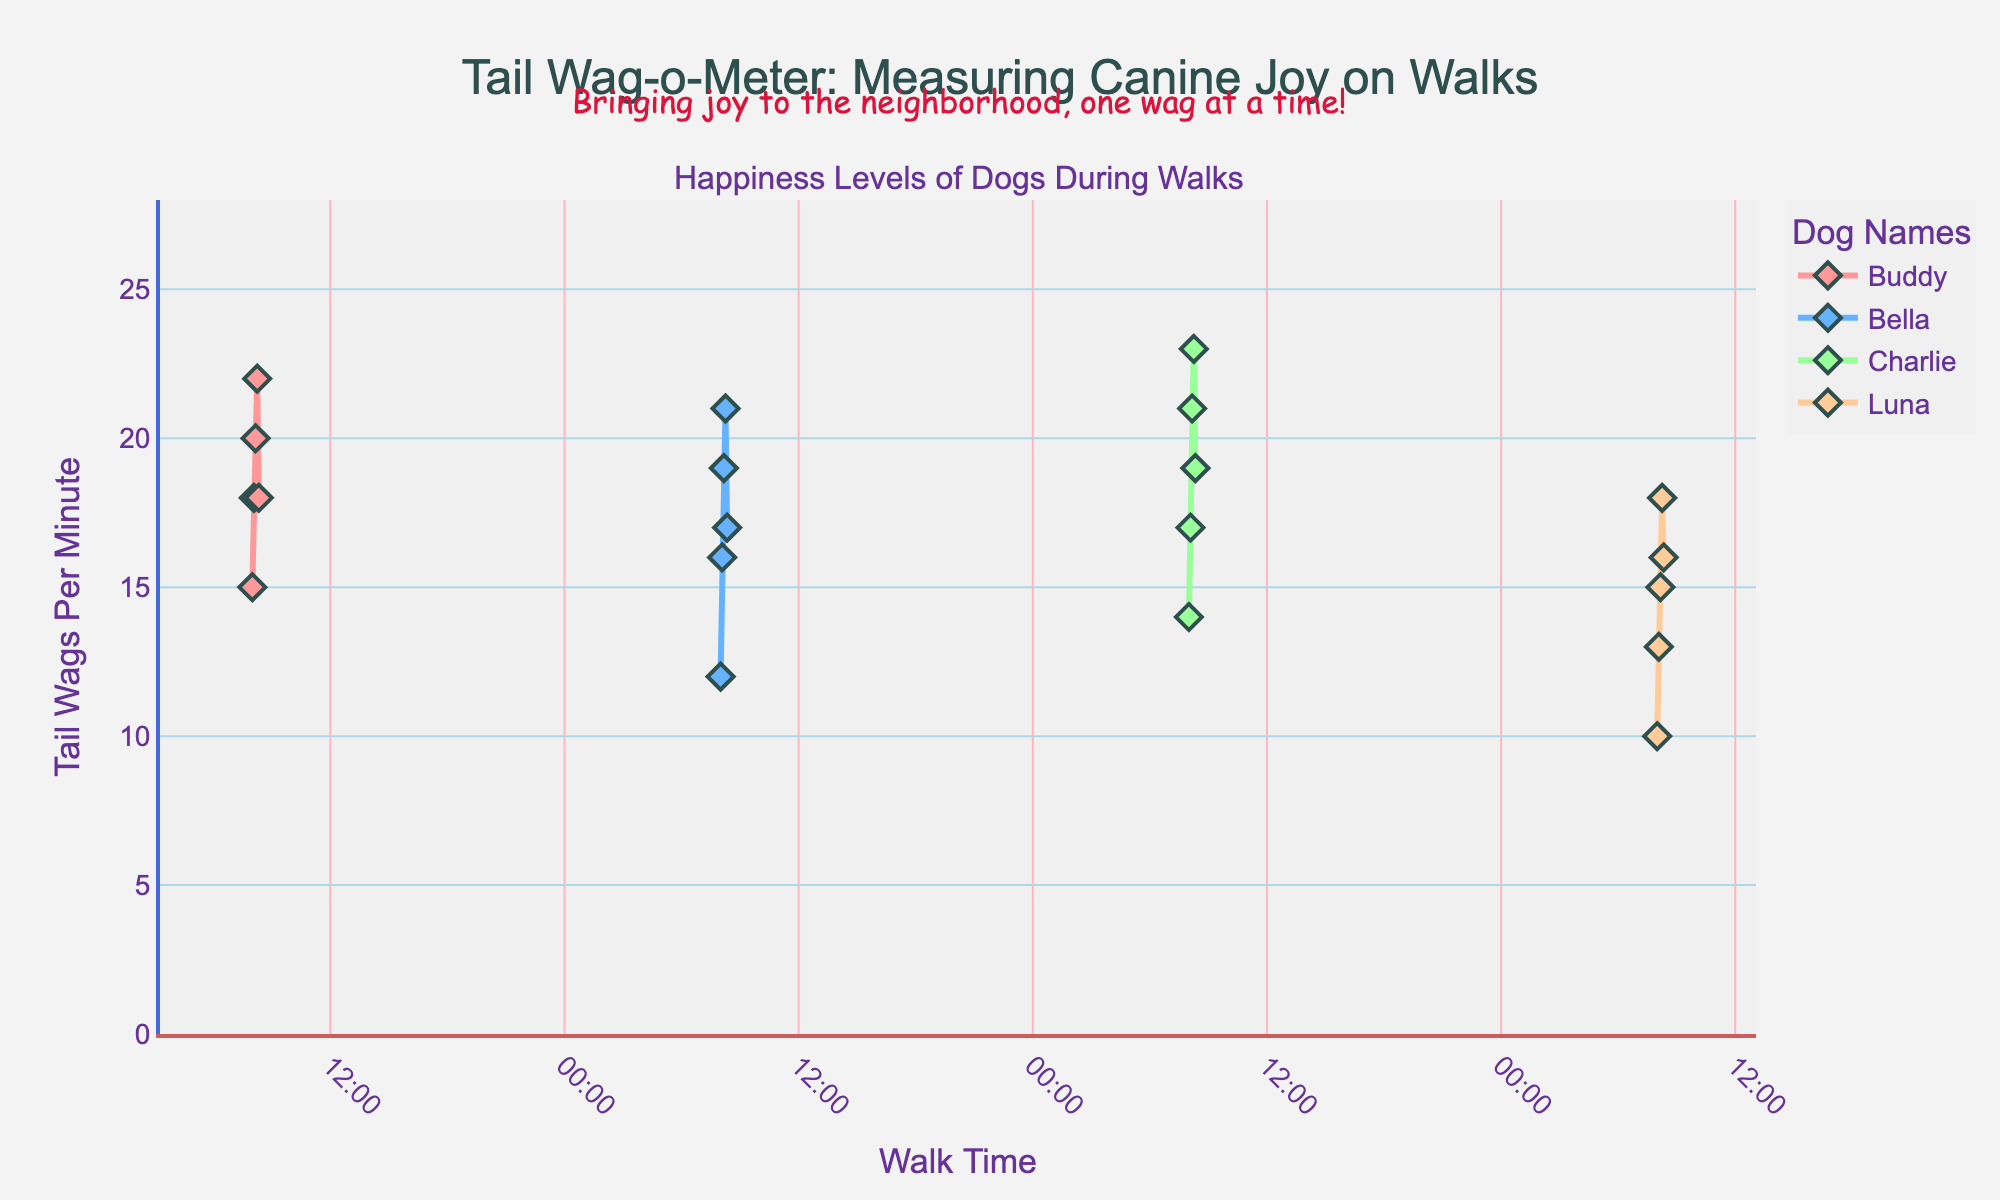What is the title of the plot? The title is written at the top of the plot within quotation marks.
Answer: "Tail Wag-o-Meter: Measuring Canine Joy on Walks" Which dog had the highest Tail Wags Per Minute during any of the recorded walks? By examining the peaks in the lines, Charlie had the highest Tail Wags Per Minute at 23.
Answer: Charlie Which dog had the lowest initial Tail Wags Per Minute during their walk? Look at the y-coordinate of the starting point (first data point) for each dog's line. Luna starts with the lowest at 10 wags per minute at 8:00.
Answer: Luna Compare Buddy's and Bella's Tail Wags Per Minute at 08:10. Who had more? At 08:10, check the y-values of Buddy and Bella. Buddy had 20, while Bella had 19.
Answer: Buddy What is the range of Tail Wags Per Minute data displayed on the y-axis? The y-axis labels range from the minimum value, which is slightly below the lowest data point (10), to the maximum value, which is slightly above the highest data point (23). The range is from 0 to a bit above 23.
Answer: 0 to 28 On which date was the annotation "Bringing joy to the neighborhood, one wag at a time!" added? The annotation is placed on the plot, away from the individual data points, so it is not linked to any particular date. This is a general annotation.
Answer: General annotation What was the average Tail Wags Per Minute for Charlie during the recorded walk? Calculate the average by summing Charlie's Tail Wags Per Minute data points (14+17+21+23+19) and dividing by the number of points (5). (14+17+21+23+19)/5 = 18.8
Answer: 18.8 What is the dog-name legend title listed in the figure? The legend title is placed near the legend that lists all dog names.
Answer: Dog Names For Bella, what was the increase in Tail Wags Per Minute from 08:00 to 08:10? Subtract the value at 08:00 (12) from the value at 08:10 (19). 19 - 12 = 7
Answer: 7 How does the background color of the plot appear? The description notes the plot and paper background color as 'rgba(240,240,240,0.8)', which gives a light grayish appearance.
Answer: Light grayish 